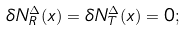<formula> <loc_0><loc_0><loc_500><loc_500>\delta N _ { R } ^ { \Delta } ( x ) = \delta N _ { T } ^ { \Delta } ( x ) = 0 ;</formula> 